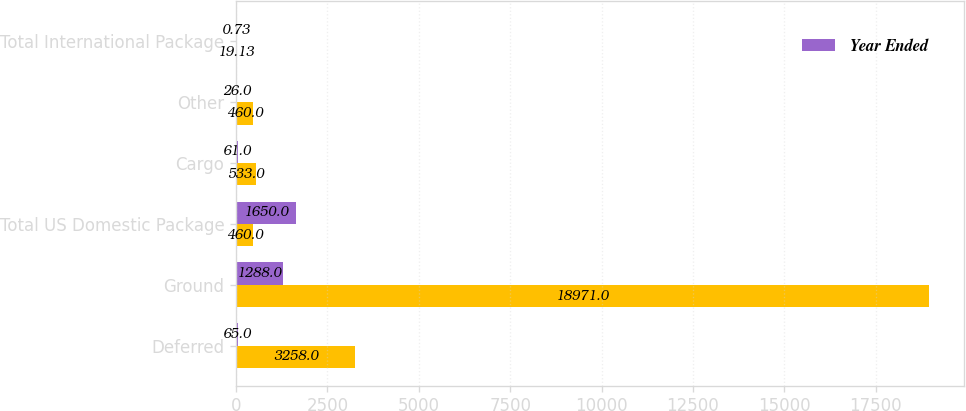<chart> <loc_0><loc_0><loc_500><loc_500><stacked_bar_chart><ecel><fcel>Deferred<fcel>Ground<fcel>Total US Domestic Package<fcel>Cargo<fcel>Other<fcel>Total International Package<nl><fcel>nan<fcel>3258<fcel>18971<fcel>460<fcel>533<fcel>460<fcel>19.13<nl><fcel>Year Ended<fcel>65<fcel>1288<fcel>1650<fcel>61<fcel>26<fcel>0.73<nl></chart> 